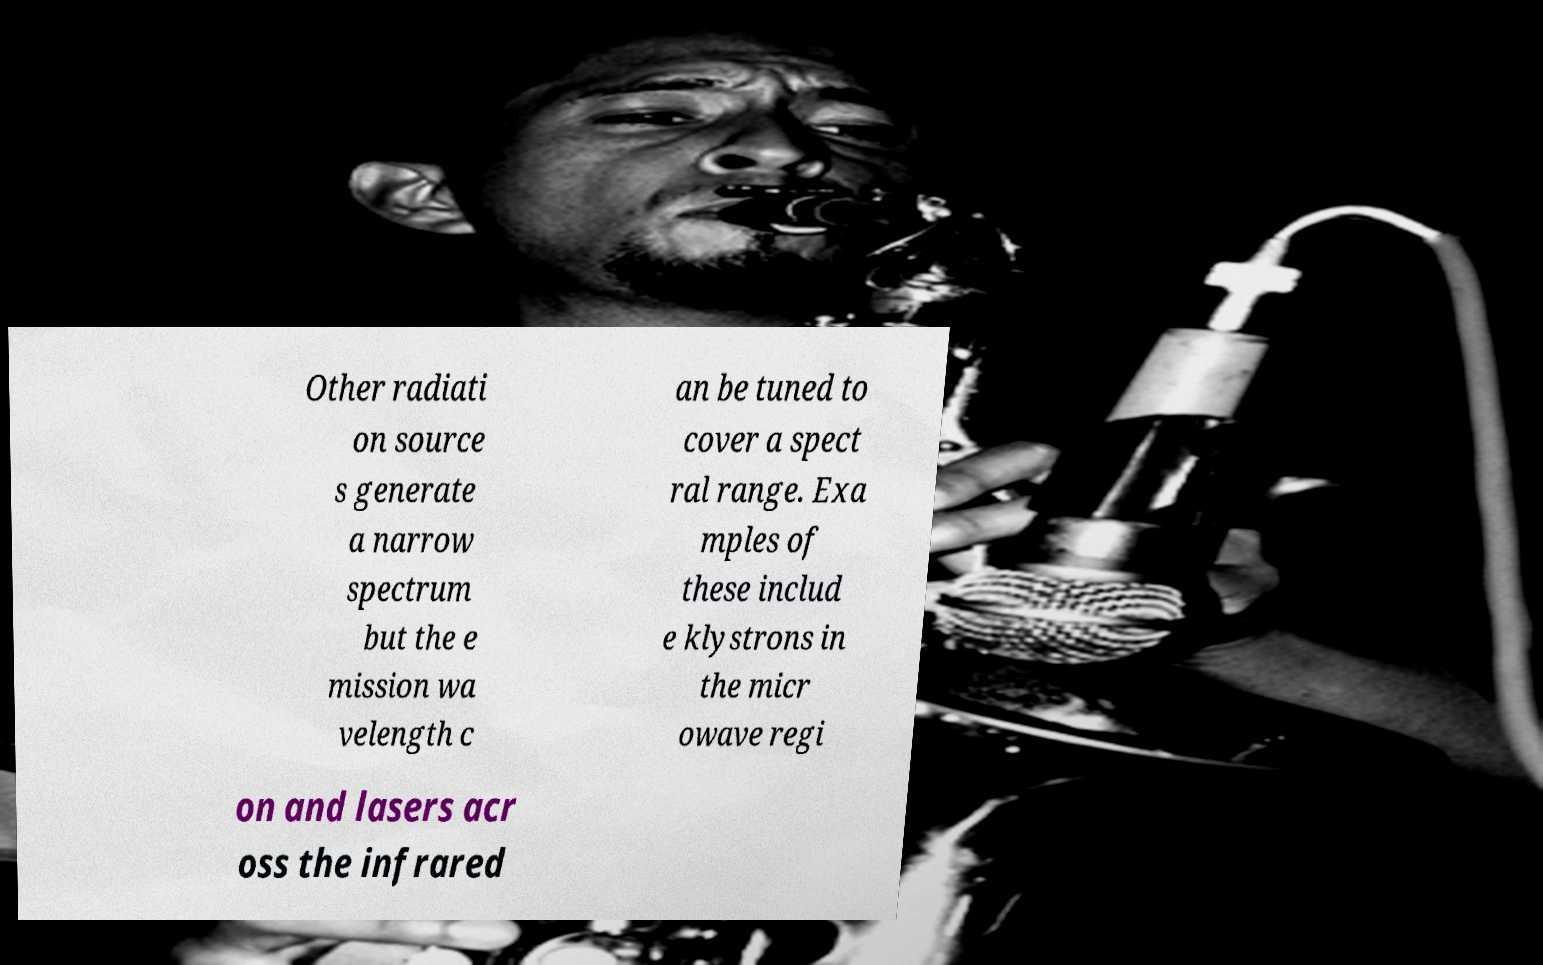For documentation purposes, I need the text within this image transcribed. Could you provide that? Other radiati on source s generate a narrow spectrum but the e mission wa velength c an be tuned to cover a spect ral range. Exa mples of these includ e klystrons in the micr owave regi on and lasers acr oss the infrared 